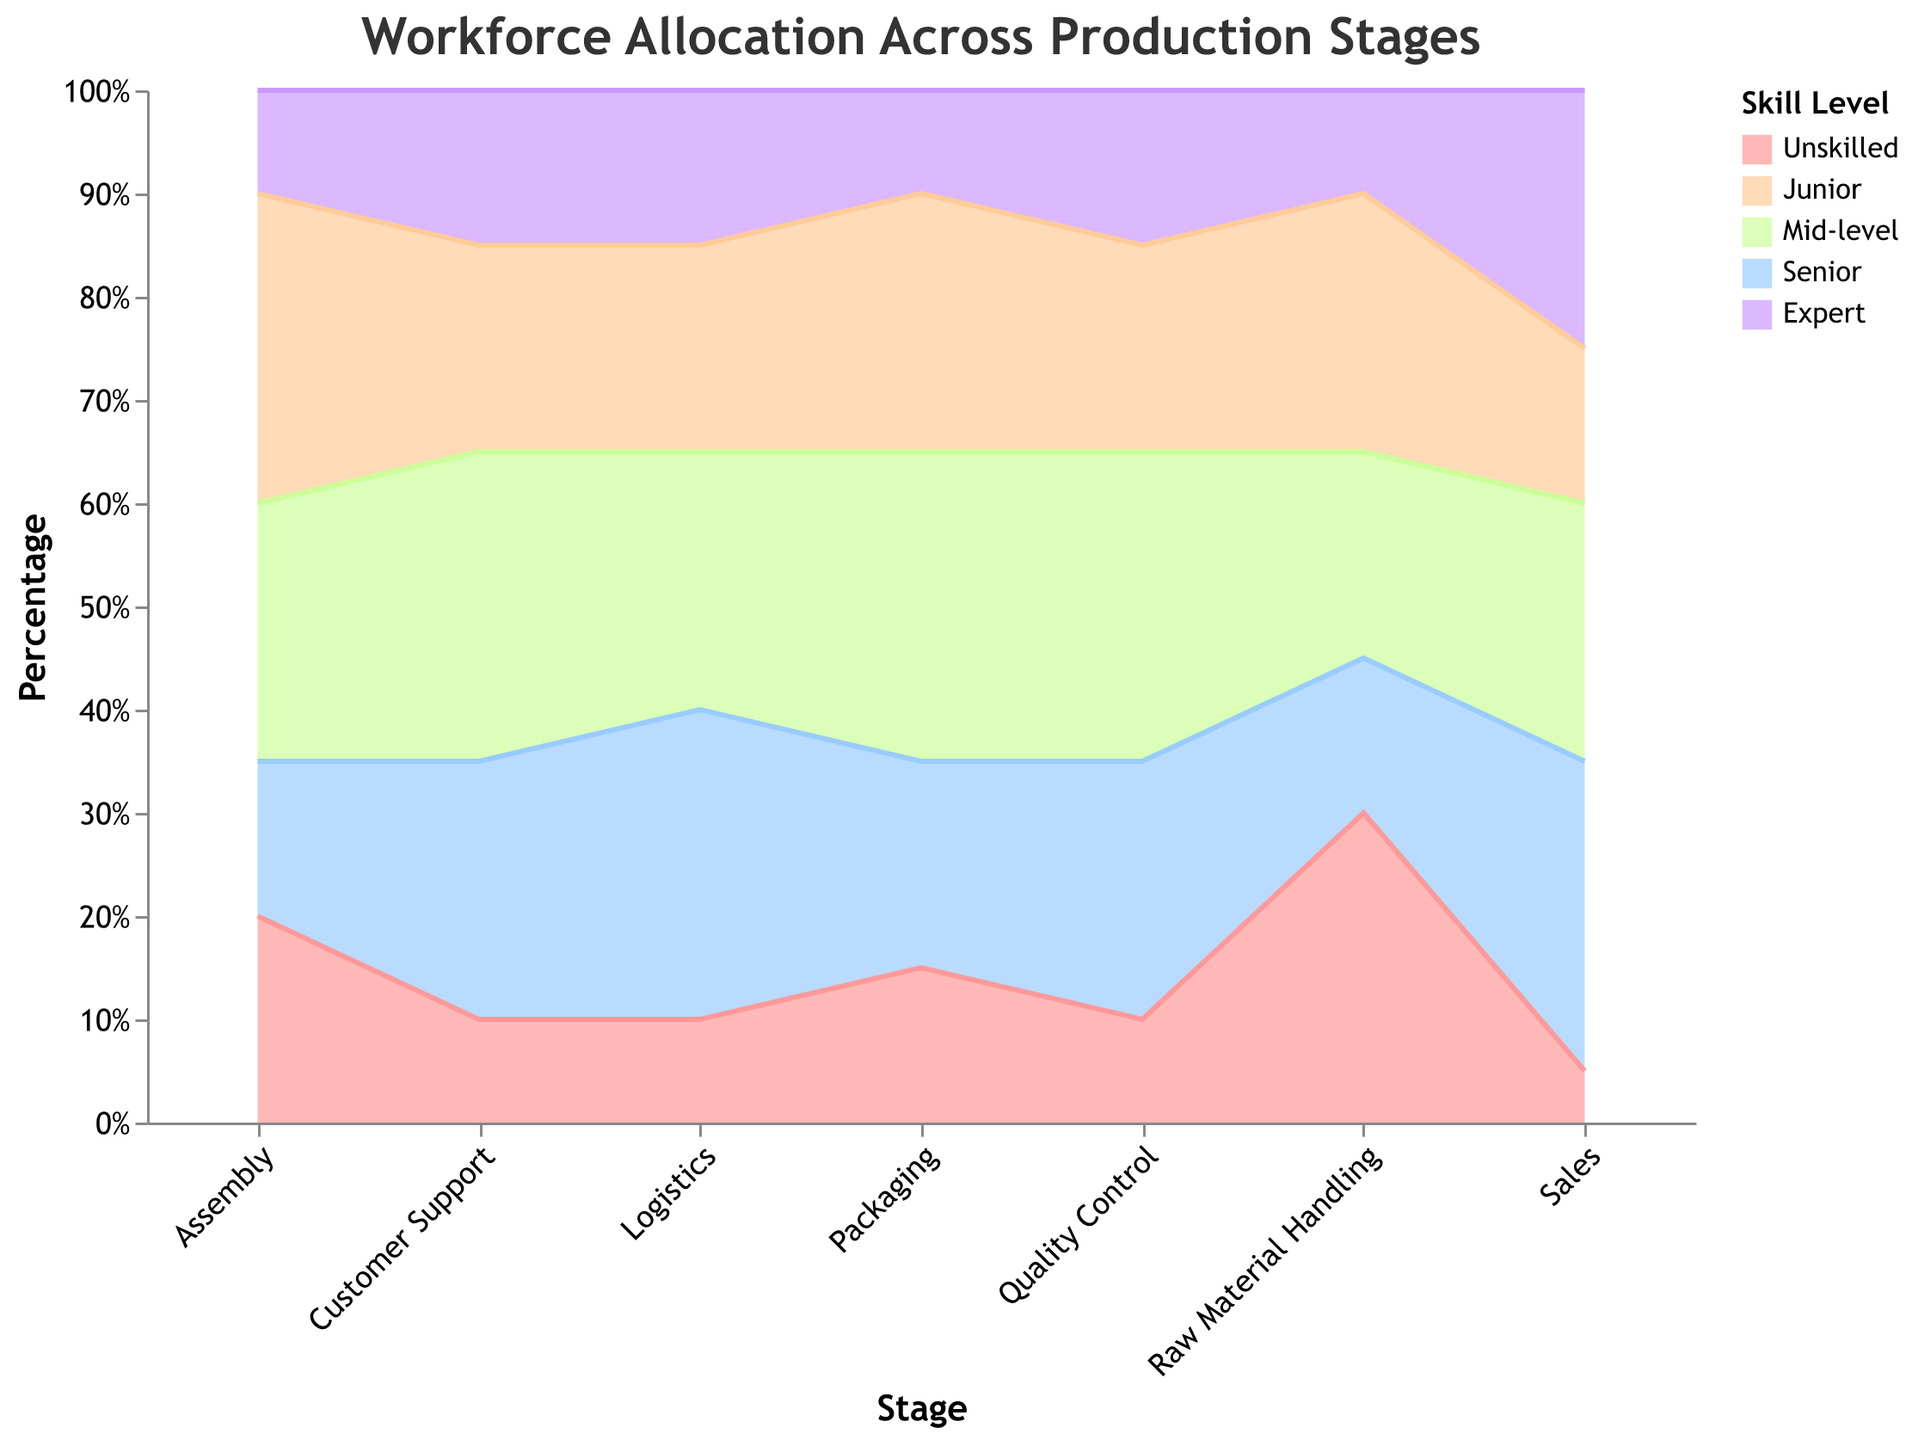What is the title of the chart? The title of the chart is displayed at the top and it reads "Workforce Allocation Across Production Stages".
Answer: Workforce Allocation Across Production Stages What are the skill levels represented by different colors in the chart? Different colors represent different skill levels. By examining the legend on the right, the skill levels are Unskilled, Junior, Mid-level, Senior, and Expert.
Answer: Unskilled, Junior, Mid-level, Senior, Expert In which production stage do Senior and Expert workers combined have the largest workforce proportion? Looking at the stacked areas for Senior and Expert skill levels across stages, the Sales stage has the greatest combined area for these skill levels.
Answer: Sales Which production stage has the lowest percentage of Unskilled workers? By examining the lowest areas corresponding to Unskilled workers, the Sales stage has the smallest percentage.
Answer: Sales In which stage does the Junior workforce have the highest percentage? The highest area for Junior workers is in the Assembly stage.
Answer: Assembly What is the percentage range for Mid-level workers across all stages? The Mid-level worker's area varies across stages but remains between approximately 20% and 30%.
Answer: 20%-30% How does the proportion of Expert workers in Packaging compare to that in Quality Control? The proportion of Expert workers in Packaging is lower than in Quality Control.
Answer: Lower Which stages have an exactly equal percentage representation for Mid-level workers? Mid-level workers have an equal representation in Assembly and Customer Support stages, both stages show 30%.
Answer: Assembly, Customer Support What is the combined percentage of Unskilled workers in the first and last stages? The proportion of Unskilled workers is 30% in Raw Material Handling and 10% in Customer Support, combined it is 40%.
Answer: 40% Is there a stage where Junior workers have a lower percentage than Expert workers? No, in all stages, Junior workers always have a higher percentage compared to Expert workers.
Answer: No 